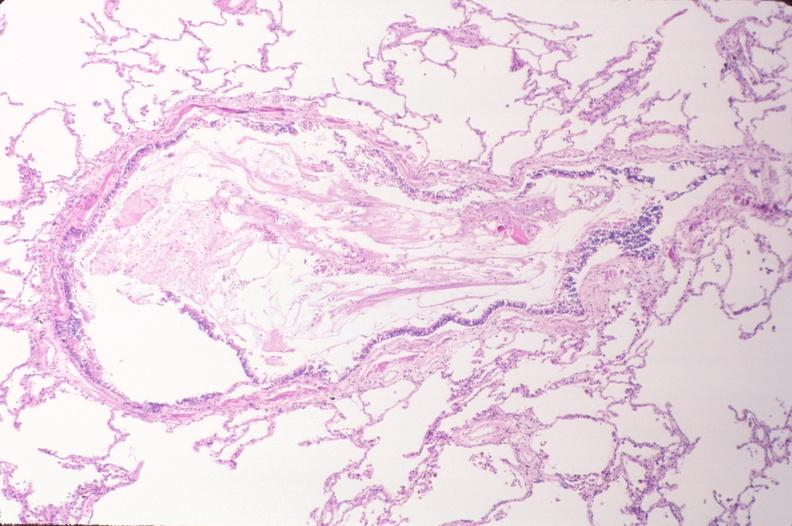does metastatic neuroblastoma show lung, emphysema and bronchial plugging in a chronic smoker?
Answer the question using a single word or phrase. No 